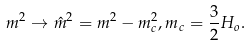<formula> <loc_0><loc_0><loc_500><loc_500>m ^ { 2 } \to \hat { m } ^ { 2 } = m ^ { 2 } - m _ { c } ^ { 2 } , m _ { c } = \frac { 3 } { 2 } H _ { o } .</formula> 